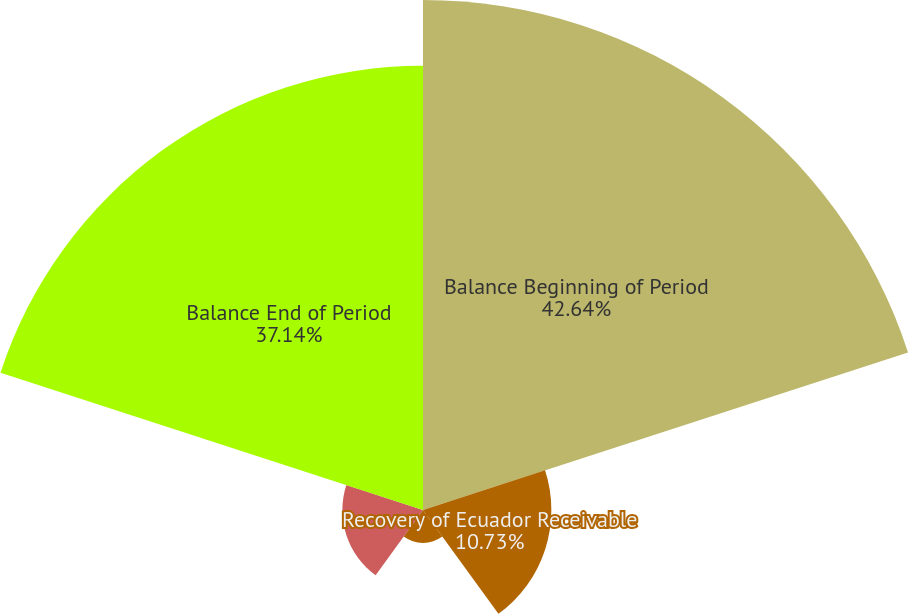<chart> <loc_0><loc_0><loc_500><loc_500><pie_chart><fcel>Balance Beginning of Period<fcel>Recovery of Ecuador Receivable<fcel>Other Changes<fcel>Net Changes Before Write-offs<fcel>Balance End of Period<nl><fcel>42.64%<fcel>10.73%<fcel>2.75%<fcel>6.74%<fcel>37.14%<nl></chart> 